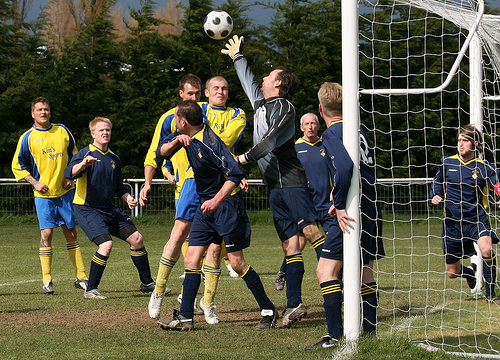<image>
Is there a man under the ball? No. The man is not positioned under the ball. The vertical relationship between these objects is different. Is there a ball above the guy? Yes. The ball is positioned above the guy in the vertical space, higher up in the scene. 